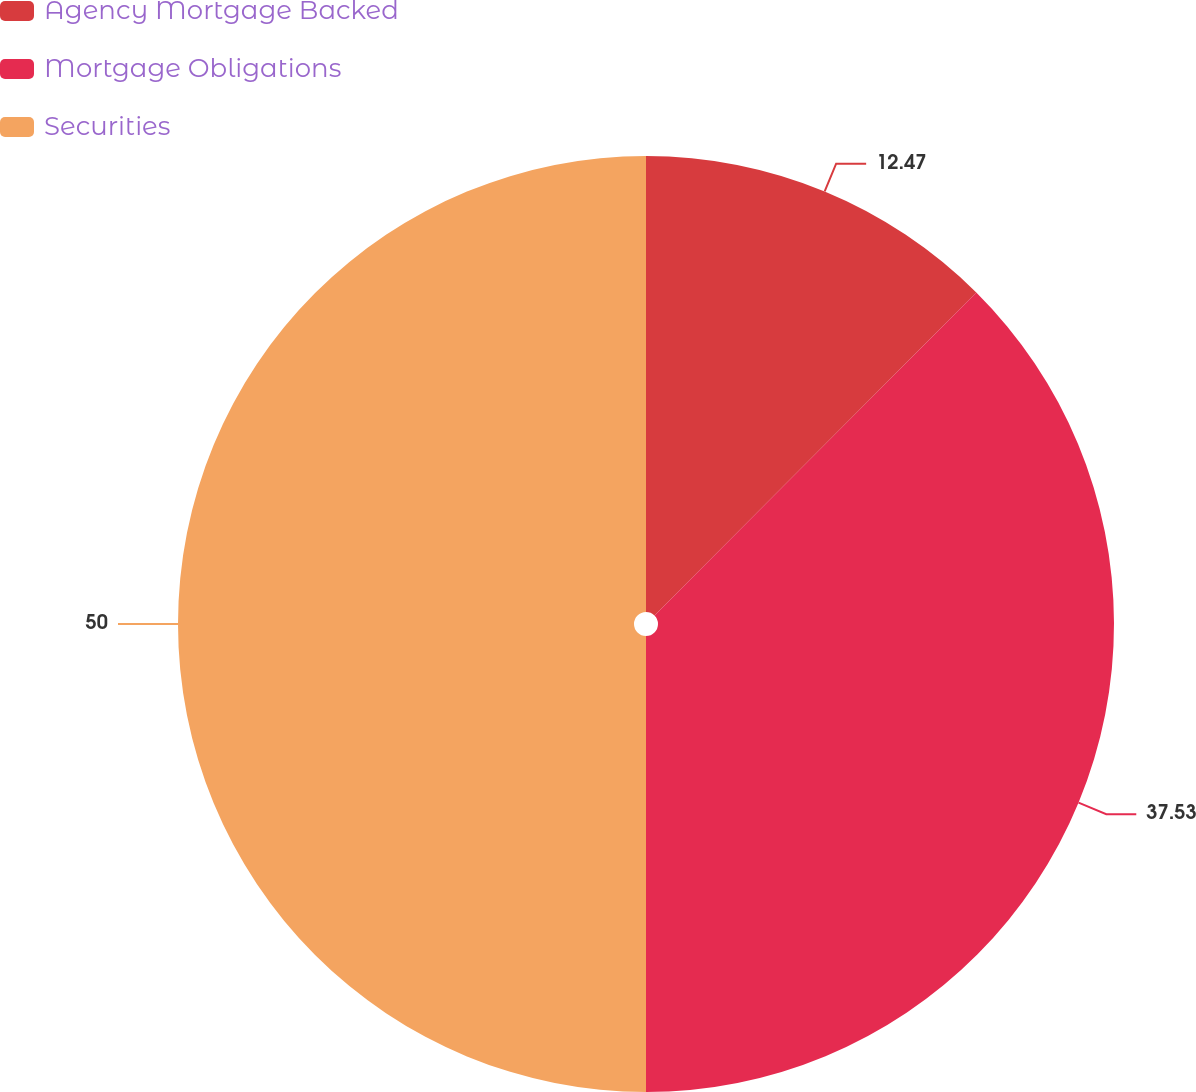Convert chart. <chart><loc_0><loc_0><loc_500><loc_500><pie_chart><fcel>Agency Mortgage Backed<fcel>Mortgage Obligations<fcel>Securities<nl><fcel>12.47%<fcel>37.53%<fcel>50.0%<nl></chart> 